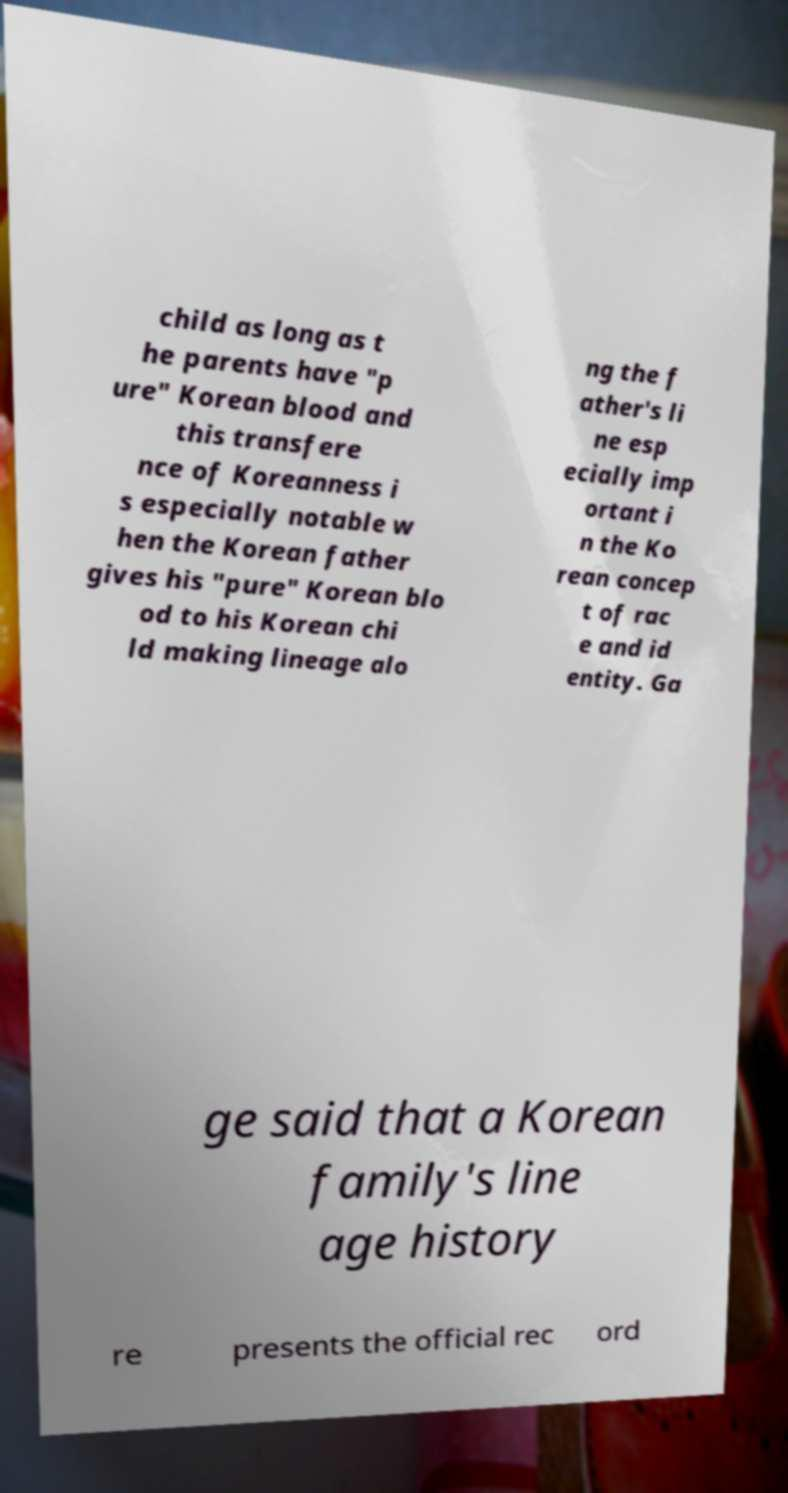Can you read and provide the text displayed in the image?This photo seems to have some interesting text. Can you extract and type it out for me? child as long as t he parents have "p ure" Korean blood and this transfere nce of Koreanness i s especially notable w hen the Korean father gives his "pure" Korean blo od to his Korean chi ld making lineage alo ng the f ather's li ne esp ecially imp ortant i n the Ko rean concep t of rac e and id entity. Ga ge said that a Korean family's line age history re presents the official rec ord 